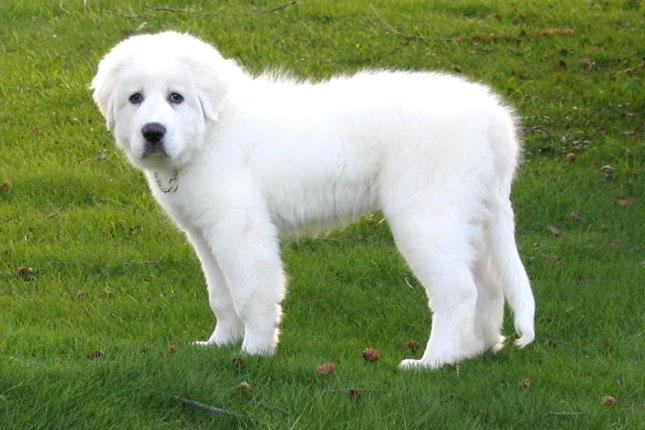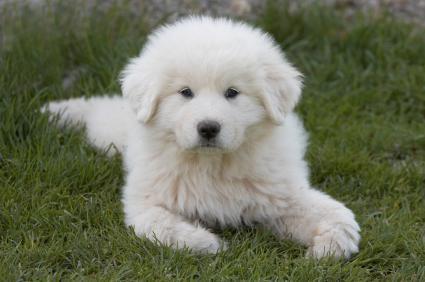The first image is the image on the left, the second image is the image on the right. Examine the images to the left and right. Is the description "In at least one of the images, a white dog is laying down in grass" accurate? Answer yes or no. Yes. The first image is the image on the left, the second image is the image on the right. Given the left and right images, does the statement "The right image contains one white dog that is laying down in the grass." hold true? Answer yes or no. Yes. 